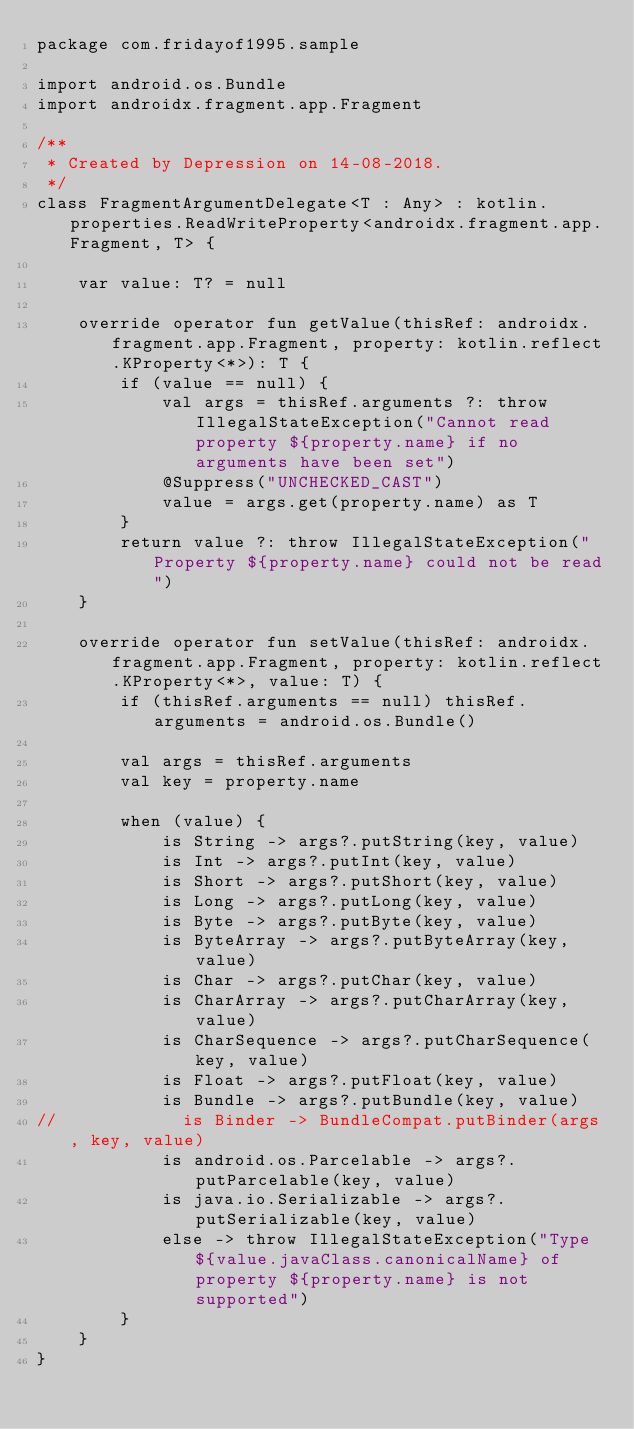<code> <loc_0><loc_0><loc_500><loc_500><_Kotlin_>package com.fridayof1995.sample

import android.os.Bundle
import androidx.fragment.app.Fragment

/**
 * Created by Depression on 14-08-2018.
 */
class FragmentArgumentDelegate<T : Any> : kotlin.properties.ReadWriteProperty<androidx.fragment.app.Fragment, T> {

    var value: T? = null

    override operator fun getValue(thisRef: androidx.fragment.app.Fragment, property: kotlin.reflect.KProperty<*>): T {
        if (value == null) {
            val args = thisRef.arguments ?: throw IllegalStateException("Cannot read property ${property.name} if no arguments have been set")
            @Suppress("UNCHECKED_CAST")
            value = args.get(property.name) as T
        }
        return value ?: throw IllegalStateException("Property ${property.name} could not be read")
    }

    override operator fun setValue(thisRef: androidx.fragment.app.Fragment, property: kotlin.reflect.KProperty<*>, value: T) {
        if (thisRef.arguments == null) thisRef.arguments = android.os.Bundle()

        val args = thisRef.arguments
        val key = property.name

        when (value) {
            is String -> args?.putString(key, value)
            is Int -> args?.putInt(key, value)
            is Short -> args?.putShort(key, value)
            is Long -> args?.putLong(key, value)
            is Byte -> args?.putByte(key, value)
            is ByteArray -> args?.putByteArray(key, value)
            is Char -> args?.putChar(key, value)
            is CharArray -> args?.putCharArray(key, value)
            is CharSequence -> args?.putCharSequence(key, value)
            is Float -> args?.putFloat(key, value)
            is Bundle -> args?.putBundle(key, value)
//            is Binder -> BundleCompat.putBinder(args, key, value)
            is android.os.Parcelable -> args?.putParcelable(key, value)
            is java.io.Serializable -> args?.putSerializable(key, value)
            else -> throw IllegalStateException("Type ${value.javaClass.canonicalName} of property ${property.name} is not supported")
        }
    }
}</code> 